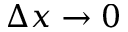<formula> <loc_0><loc_0><loc_500><loc_500>\Delta x \to 0</formula> 